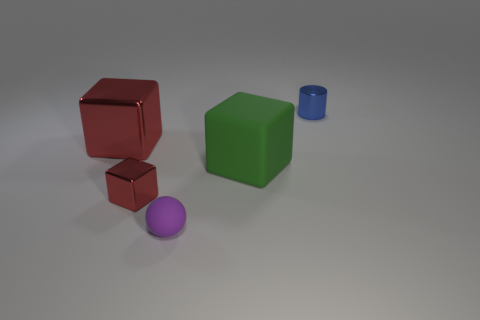Is there anything else that is the same shape as the small rubber object?
Keep it short and to the point. No. Are there fewer large red metallic blocks on the right side of the large red shiny thing than big blocks that are to the left of the tiny blue metallic cylinder?
Offer a terse response. Yes. What size is the matte object right of the small purple thing?
Ensure brevity in your answer.  Large. Does the blue metallic object have the same size as the matte sphere?
Your response must be concise. Yes. What number of objects are both behind the small red shiny block and left of the rubber ball?
Provide a succinct answer. 1. How many yellow things are either spheres or big cubes?
Provide a short and direct response. 0. What number of rubber objects are either big red cubes or tiny blue cylinders?
Offer a terse response. 0. Are there any tiny cyan cubes?
Provide a succinct answer. No. Is the shape of the large green object the same as the small red metal thing?
Offer a terse response. Yes. There is a metallic object to the right of the small shiny object that is on the left side of the tiny metallic cylinder; what number of small things are in front of it?
Make the answer very short. 2. 